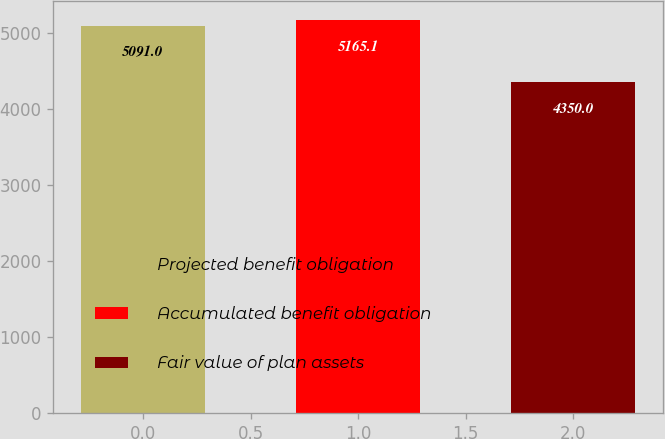<chart> <loc_0><loc_0><loc_500><loc_500><bar_chart><fcel>Projected benefit obligation<fcel>Accumulated benefit obligation<fcel>Fair value of plan assets<nl><fcel>5091<fcel>5165.1<fcel>4350<nl></chart> 